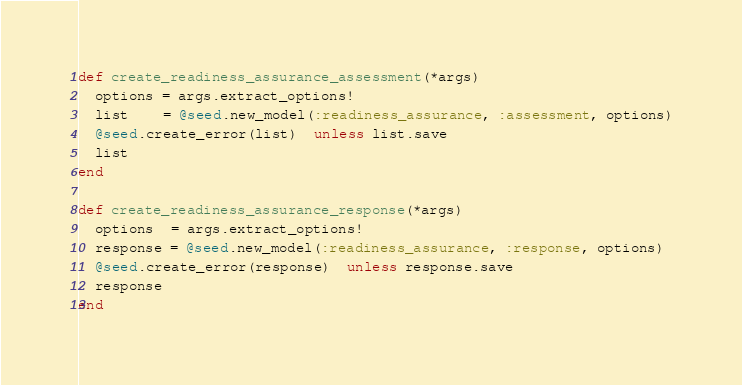<code> <loc_0><loc_0><loc_500><loc_500><_Ruby_>def create_readiness_assurance_assessment(*args)
  options = args.extract_options!
  list    = @seed.new_model(:readiness_assurance, :assessment, options)
  @seed.create_error(list)  unless list.save
  list
end

def create_readiness_assurance_response(*args)
  options  = args.extract_options!
  response = @seed.new_model(:readiness_assurance, :response, options)
  @seed.create_error(response)  unless response.save
  response
end
</code> 